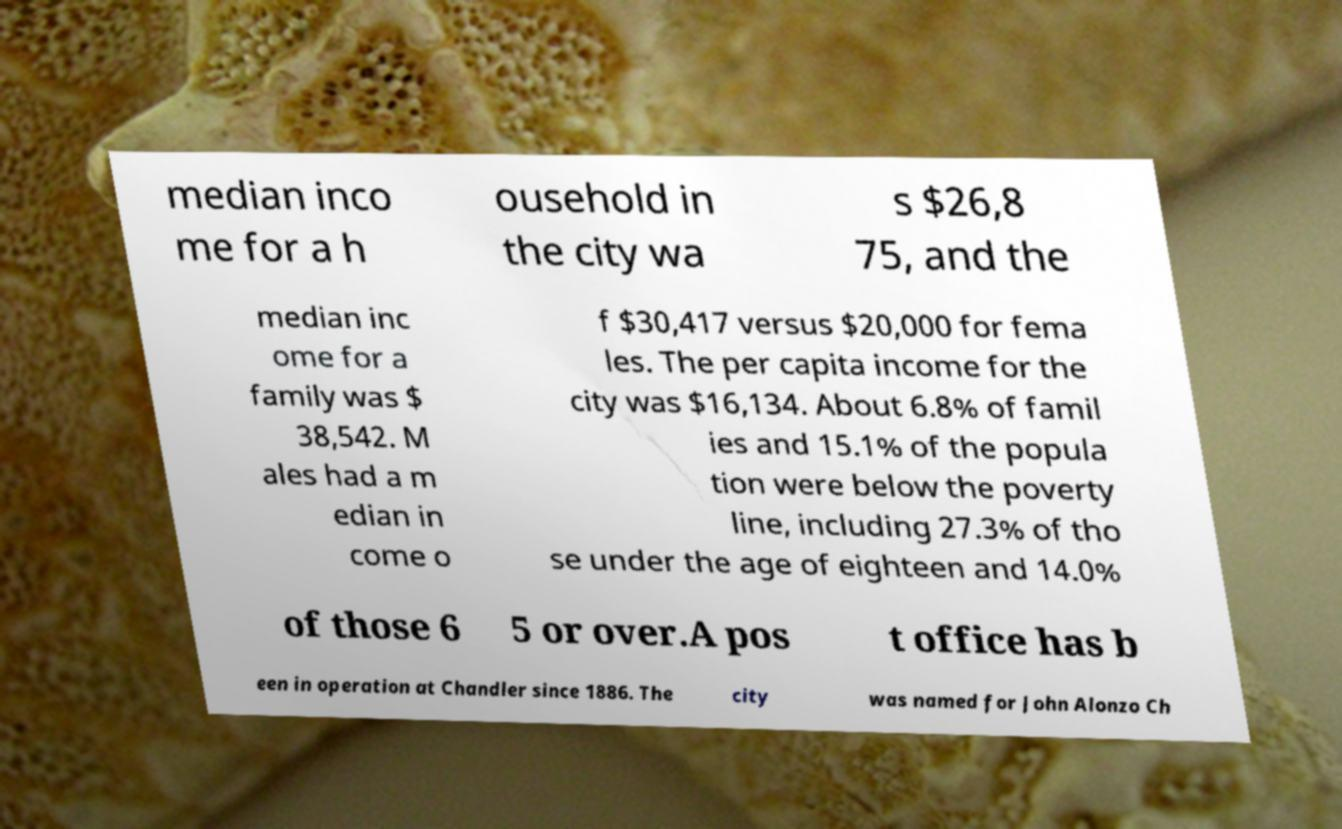What messages or text are displayed in this image? I need them in a readable, typed format. median inco me for a h ousehold in the city wa s $26,8 75, and the median inc ome for a family was $ 38,542. M ales had a m edian in come o f $30,417 versus $20,000 for fema les. The per capita income for the city was $16,134. About 6.8% of famil ies and 15.1% of the popula tion were below the poverty line, including 27.3% of tho se under the age of eighteen and 14.0% of those 6 5 or over.A pos t office has b een in operation at Chandler since 1886. The city was named for John Alonzo Ch 